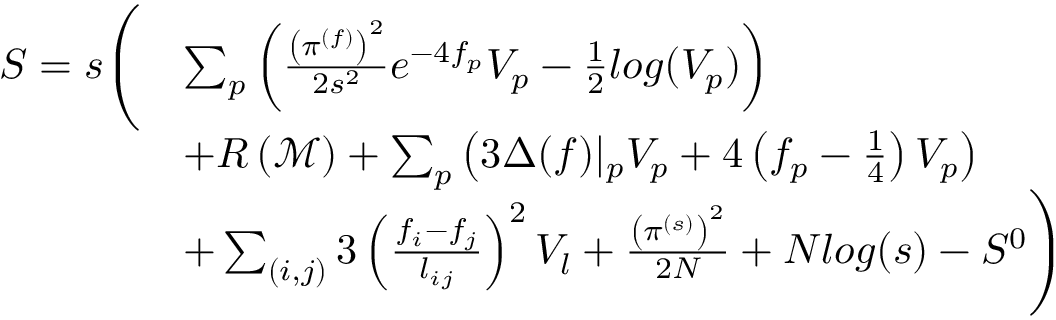Convert formula to latex. <formula><loc_0><loc_0><loc_500><loc_500>\begin{array} { r l } { S = s \left ( } & { \sum _ { p } \left ( \frac { \left ( \pi ^ { ( f ) } \right ) ^ { 2 } } { 2 s ^ { 2 } } e ^ { - 4 f _ { p } } V _ { p } - \frac { 1 } { 2 } \log ( V _ { p } ) \right ) } \\ & { + R \left ( \mathcal { M } \right ) + \sum _ { p } \left ( 3 \Delta ( f ) | _ { p } V _ { p } + 4 \left ( f _ { p } - \frac { 1 } { 4 } \right ) V _ { p } \right ) } \\ & { + \sum _ { ( i , j ) } 3 \left ( \frac { f _ { i } - f _ { j } } { l _ { i j } } \right ) ^ { 2 } V _ { l } + \frac { \left ( \pi ^ { ( s ) } \right ) ^ { 2 } } { 2 N } + N \log ( s ) - S ^ { 0 } \right ) } \end{array}</formula> 